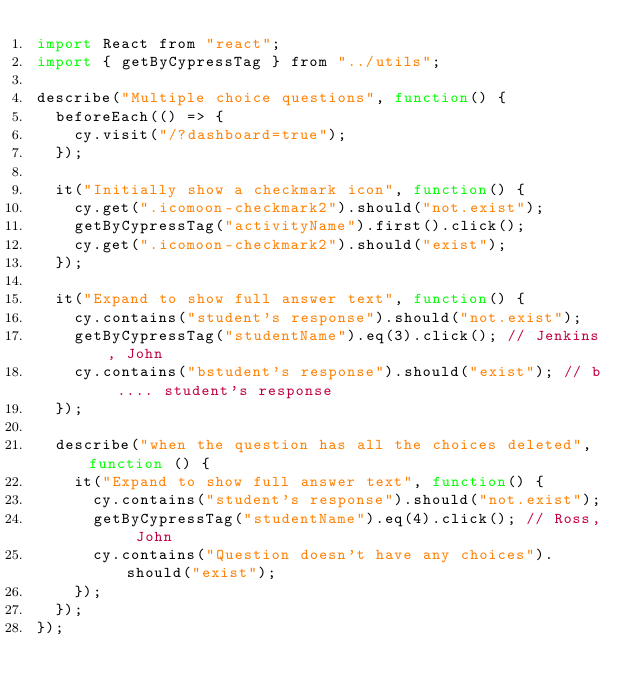<code> <loc_0><loc_0><loc_500><loc_500><_JavaScript_>import React from "react";
import { getByCypressTag } from "../utils";

describe("Multiple choice questions", function() {
  beforeEach(() => {
    cy.visit("/?dashboard=true");
  });

  it("Initially show a checkmark icon", function() {
    cy.get(".icomoon-checkmark2").should("not.exist");
    getByCypressTag("activityName").first().click();
    cy.get(".icomoon-checkmark2").should("exist");
  });

  it("Expand to show full answer text", function() {
    cy.contains("student's response").should("not.exist");
    getByCypressTag("studentName").eq(3).click(); // Jenkins, John
    cy.contains("bstudent's response").should("exist"); // b .... student's response
  });

  describe("when the question has all the choices deleted", function () {
    it("Expand to show full answer text", function() {
      cy.contains("student's response").should("not.exist");
      getByCypressTag("studentName").eq(4).click(); // Ross, John
      cy.contains("Question doesn't have any choices").should("exist");
    });
  });
});
</code> 